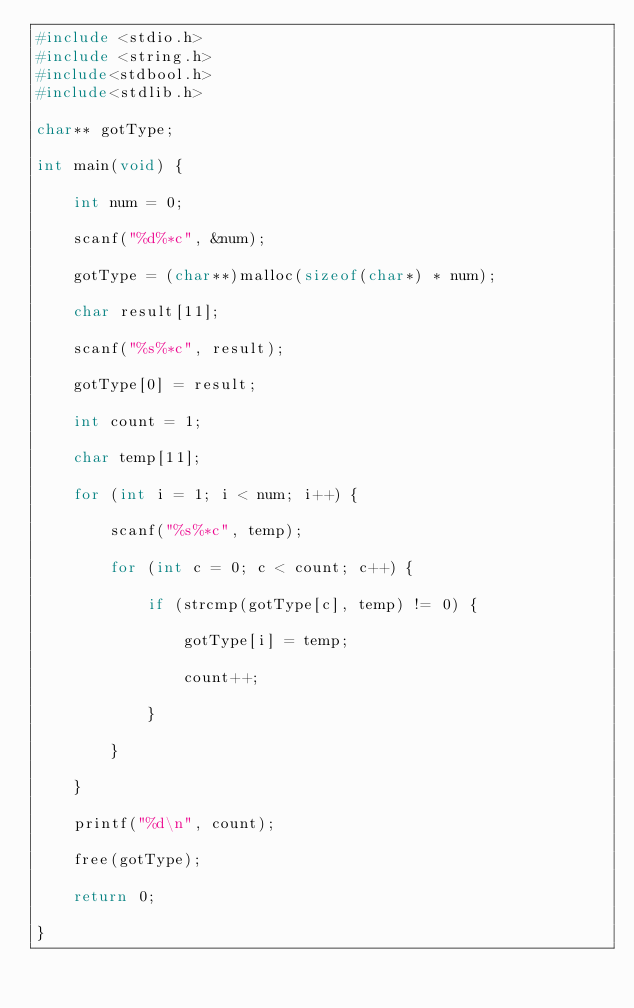<code> <loc_0><loc_0><loc_500><loc_500><_C_>#include <stdio.h>
#include <string.h>
#include<stdbool.h>
#include<stdlib.h>

char** gotType;

int main(void) {

	int num = 0;

	scanf("%d%*c", &num);

	gotType = (char**)malloc(sizeof(char*) * num);

	char result[11];

	scanf("%s%*c", result);

	gotType[0] = result;

	int count = 1;

	char temp[11];

	for (int i = 1; i < num; i++) {

		scanf("%s%*c", temp);

		for (int c = 0; c < count; c++) {

			if (strcmp(gotType[c], temp) != 0) {

				gotType[i] = temp;

				count++;

			}

		}

	}

	printf("%d\n", count);

	free(gotType);

	return 0;

}</code> 